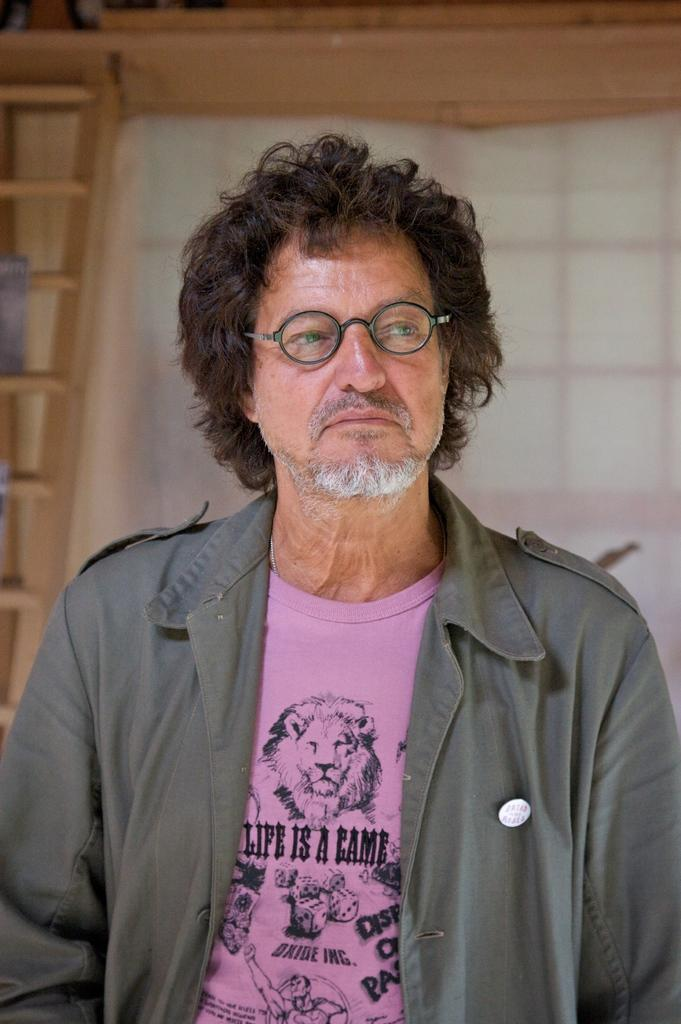Who is the main subject in the picture? There is an old man in the picture. What is the old man wearing? The old man is wearing a grey jacket and a pink t-shirt. Which direction is the old man looking? The old man is looking to the right. What can be seen in the background of the picture? There is a white curtain and a brown window in the background. What is the old man's annual income in the image? There is no information about the old man's income in the image. How does the old man use magic to create sand in the image? There is no mention of magic or sand in the image; it only features an old man, his clothing, and the background elements. 